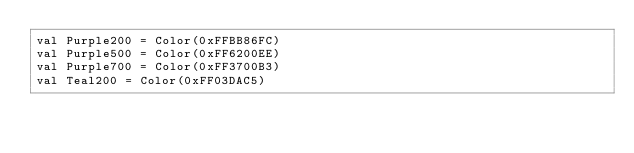Convert code to text. <code><loc_0><loc_0><loc_500><loc_500><_Kotlin_>val Purple200 = Color(0xFFBB86FC)
val Purple500 = Color(0xFF6200EE)
val Purple700 = Color(0xFF3700B3)
val Teal200 = Color(0xFF03DAC5)</code> 